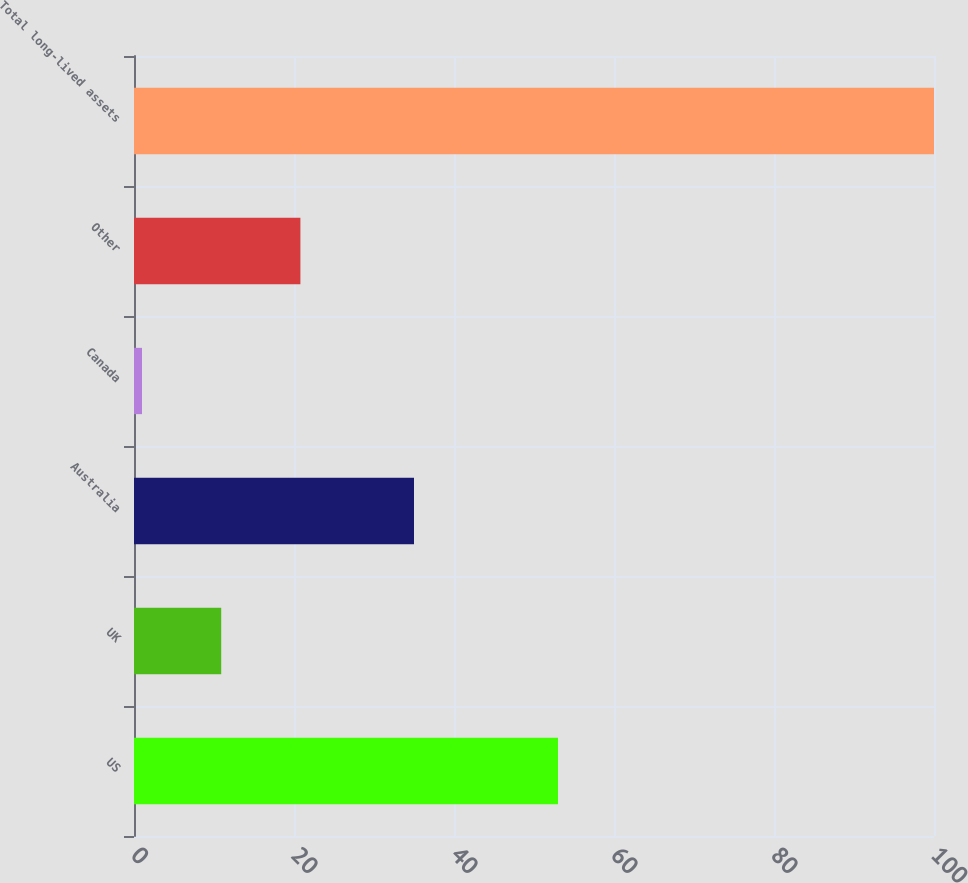Convert chart. <chart><loc_0><loc_0><loc_500><loc_500><bar_chart><fcel>US<fcel>UK<fcel>Australia<fcel>Canada<fcel>Other<fcel>Total long-lived assets<nl><fcel>53<fcel>10.9<fcel>35<fcel>1<fcel>20.8<fcel>100<nl></chart> 